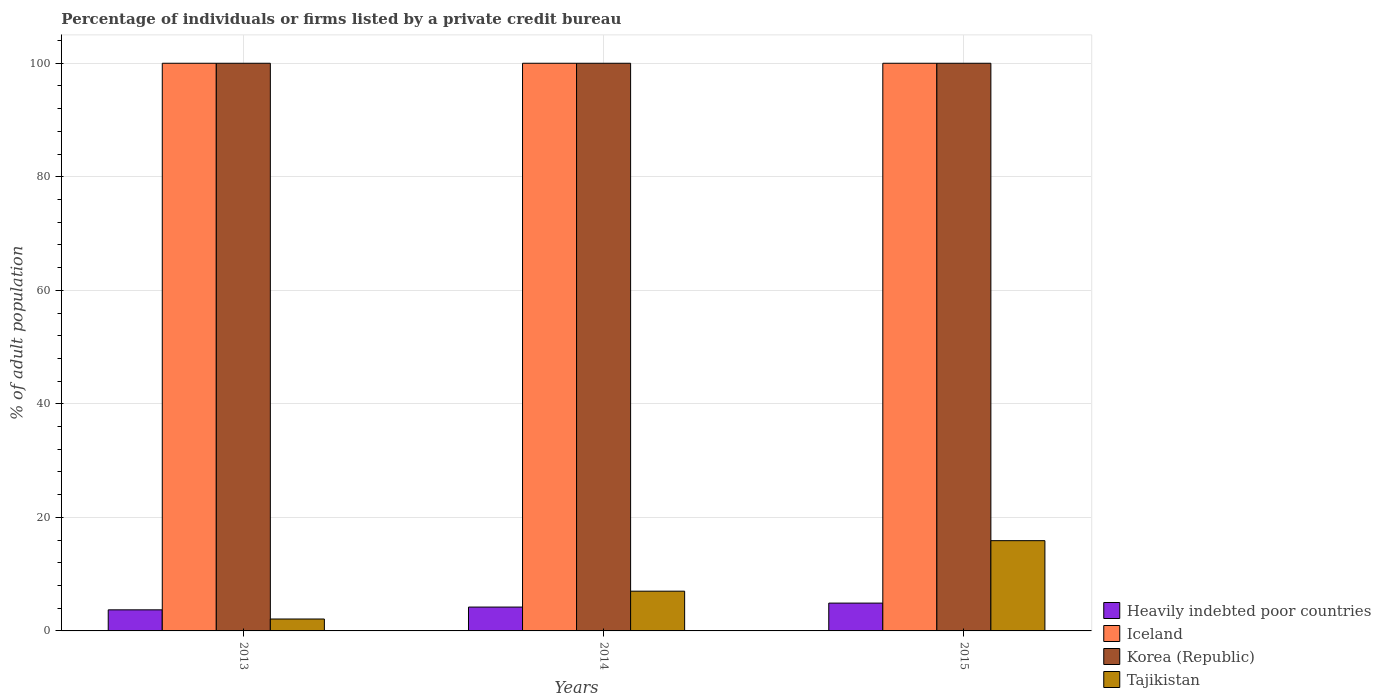How many groups of bars are there?
Your answer should be compact. 3. How many bars are there on the 3rd tick from the left?
Offer a very short reply. 4. What is the label of the 3rd group of bars from the left?
Offer a very short reply. 2015. What is the percentage of population listed by a private credit bureau in Iceland in 2014?
Ensure brevity in your answer.  100. In which year was the percentage of population listed by a private credit bureau in Iceland maximum?
Make the answer very short. 2013. In which year was the percentage of population listed by a private credit bureau in Iceland minimum?
Give a very brief answer. 2013. What is the total percentage of population listed by a private credit bureau in Korea (Republic) in the graph?
Your answer should be compact. 300. What is the difference between the percentage of population listed by a private credit bureau in Heavily indebted poor countries in 2014 and that in 2015?
Provide a succinct answer. -0.7. What is the difference between the percentage of population listed by a private credit bureau in Iceland in 2015 and the percentage of population listed by a private credit bureau in Korea (Republic) in 2014?
Provide a succinct answer. 0. What is the average percentage of population listed by a private credit bureau in Heavily indebted poor countries per year?
Provide a short and direct response. 4.27. In the year 2015, what is the difference between the percentage of population listed by a private credit bureau in Heavily indebted poor countries and percentage of population listed by a private credit bureau in Tajikistan?
Provide a succinct answer. -11. In how many years, is the percentage of population listed by a private credit bureau in Korea (Republic) greater than 56 %?
Your answer should be very brief. 3. What is the ratio of the percentage of population listed by a private credit bureau in Tajikistan in 2014 to that in 2015?
Your answer should be very brief. 0.44. Is the difference between the percentage of population listed by a private credit bureau in Heavily indebted poor countries in 2014 and 2015 greater than the difference between the percentage of population listed by a private credit bureau in Tajikistan in 2014 and 2015?
Your answer should be very brief. Yes. What is the difference between the highest and the second highest percentage of population listed by a private credit bureau in Tajikistan?
Offer a very short reply. 8.9. What does the 1st bar from the left in 2014 represents?
Make the answer very short. Heavily indebted poor countries. What does the 4th bar from the right in 2015 represents?
Offer a terse response. Heavily indebted poor countries. Are all the bars in the graph horizontal?
Your answer should be very brief. No. Are the values on the major ticks of Y-axis written in scientific E-notation?
Provide a short and direct response. No. Does the graph contain any zero values?
Give a very brief answer. No. Where does the legend appear in the graph?
Offer a very short reply. Bottom right. How are the legend labels stacked?
Ensure brevity in your answer.  Vertical. What is the title of the graph?
Your response must be concise. Percentage of individuals or firms listed by a private credit bureau. What is the label or title of the Y-axis?
Offer a very short reply. % of adult population. What is the % of adult population of Heavily indebted poor countries in 2013?
Give a very brief answer. 3.71. What is the % of adult population in Tajikistan in 2013?
Ensure brevity in your answer.  2.1. What is the % of adult population of Heavily indebted poor countries in 2014?
Offer a very short reply. 4.2. What is the % of adult population of Iceland in 2014?
Make the answer very short. 100. What is the % of adult population in Tajikistan in 2014?
Give a very brief answer. 7. What is the % of adult population of Heavily indebted poor countries in 2015?
Give a very brief answer. 4.9. Across all years, what is the maximum % of adult population in Heavily indebted poor countries?
Offer a terse response. 4.9. Across all years, what is the maximum % of adult population of Korea (Republic)?
Keep it short and to the point. 100. Across all years, what is the maximum % of adult population of Tajikistan?
Provide a short and direct response. 15.9. Across all years, what is the minimum % of adult population of Heavily indebted poor countries?
Your answer should be very brief. 3.71. Across all years, what is the minimum % of adult population in Tajikistan?
Your answer should be very brief. 2.1. What is the total % of adult population of Heavily indebted poor countries in the graph?
Offer a terse response. 12.82. What is the total % of adult population in Iceland in the graph?
Keep it short and to the point. 300. What is the total % of adult population of Korea (Republic) in the graph?
Offer a very short reply. 300. What is the total % of adult population in Tajikistan in the graph?
Give a very brief answer. 25. What is the difference between the % of adult population in Heavily indebted poor countries in 2013 and that in 2014?
Offer a terse response. -0.49. What is the difference between the % of adult population in Iceland in 2013 and that in 2014?
Offer a very short reply. 0. What is the difference between the % of adult population of Korea (Republic) in 2013 and that in 2014?
Provide a succinct answer. 0. What is the difference between the % of adult population in Tajikistan in 2013 and that in 2014?
Make the answer very short. -4.9. What is the difference between the % of adult population of Heavily indebted poor countries in 2013 and that in 2015?
Keep it short and to the point. -1.19. What is the difference between the % of adult population of Iceland in 2013 and that in 2015?
Your response must be concise. 0. What is the difference between the % of adult population of Heavily indebted poor countries in 2014 and that in 2015?
Your answer should be very brief. -0.7. What is the difference between the % of adult population in Iceland in 2014 and that in 2015?
Your response must be concise. 0. What is the difference between the % of adult population of Korea (Republic) in 2014 and that in 2015?
Make the answer very short. 0. What is the difference between the % of adult population in Heavily indebted poor countries in 2013 and the % of adult population in Iceland in 2014?
Provide a succinct answer. -96.29. What is the difference between the % of adult population of Heavily indebted poor countries in 2013 and the % of adult population of Korea (Republic) in 2014?
Offer a terse response. -96.29. What is the difference between the % of adult population in Heavily indebted poor countries in 2013 and the % of adult population in Tajikistan in 2014?
Keep it short and to the point. -3.29. What is the difference between the % of adult population in Iceland in 2013 and the % of adult population in Korea (Republic) in 2014?
Ensure brevity in your answer.  0. What is the difference between the % of adult population of Iceland in 2013 and the % of adult population of Tajikistan in 2014?
Your answer should be compact. 93. What is the difference between the % of adult population in Korea (Republic) in 2013 and the % of adult population in Tajikistan in 2014?
Provide a short and direct response. 93. What is the difference between the % of adult population in Heavily indebted poor countries in 2013 and the % of adult population in Iceland in 2015?
Offer a very short reply. -96.29. What is the difference between the % of adult population of Heavily indebted poor countries in 2013 and the % of adult population of Korea (Republic) in 2015?
Keep it short and to the point. -96.29. What is the difference between the % of adult population of Heavily indebted poor countries in 2013 and the % of adult population of Tajikistan in 2015?
Your response must be concise. -12.19. What is the difference between the % of adult population of Iceland in 2013 and the % of adult population of Tajikistan in 2015?
Provide a succinct answer. 84.1. What is the difference between the % of adult population in Korea (Republic) in 2013 and the % of adult population in Tajikistan in 2015?
Keep it short and to the point. 84.1. What is the difference between the % of adult population of Heavily indebted poor countries in 2014 and the % of adult population of Iceland in 2015?
Provide a succinct answer. -95.8. What is the difference between the % of adult population of Heavily indebted poor countries in 2014 and the % of adult population of Korea (Republic) in 2015?
Your response must be concise. -95.8. What is the difference between the % of adult population of Heavily indebted poor countries in 2014 and the % of adult population of Tajikistan in 2015?
Provide a short and direct response. -11.7. What is the difference between the % of adult population in Iceland in 2014 and the % of adult population in Tajikistan in 2015?
Your answer should be very brief. 84.1. What is the difference between the % of adult population in Korea (Republic) in 2014 and the % of adult population in Tajikistan in 2015?
Keep it short and to the point. 84.1. What is the average % of adult population of Heavily indebted poor countries per year?
Keep it short and to the point. 4.27. What is the average % of adult population of Iceland per year?
Offer a terse response. 100. What is the average % of adult population in Korea (Republic) per year?
Provide a short and direct response. 100. What is the average % of adult population of Tajikistan per year?
Keep it short and to the point. 8.33. In the year 2013, what is the difference between the % of adult population in Heavily indebted poor countries and % of adult population in Iceland?
Offer a terse response. -96.29. In the year 2013, what is the difference between the % of adult population of Heavily indebted poor countries and % of adult population of Korea (Republic)?
Your answer should be very brief. -96.29. In the year 2013, what is the difference between the % of adult population of Heavily indebted poor countries and % of adult population of Tajikistan?
Keep it short and to the point. 1.61. In the year 2013, what is the difference between the % of adult population in Iceland and % of adult population in Tajikistan?
Make the answer very short. 97.9. In the year 2013, what is the difference between the % of adult population in Korea (Republic) and % of adult population in Tajikistan?
Your answer should be compact. 97.9. In the year 2014, what is the difference between the % of adult population in Heavily indebted poor countries and % of adult population in Iceland?
Your answer should be compact. -95.8. In the year 2014, what is the difference between the % of adult population in Heavily indebted poor countries and % of adult population in Korea (Republic)?
Keep it short and to the point. -95.8. In the year 2014, what is the difference between the % of adult population in Heavily indebted poor countries and % of adult population in Tajikistan?
Make the answer very short. -2.8. In the year 2014, what is the difference between the % of adult population of Iceland and % of adult population of Tajikistan?
Keep it short and to the point. 93. In the year 2014, what is the difference between the % of adult population of Korea (Republic) and % of adult population of Tajikistan?
Your response must be concise. 93. In the year 2015, what is the difference between the % of adult population of Heavily indebted poor countries and % of adult population of Iceland?
Make the answer very short. -95.1. In the year 2015, what is the difference between the % of adult population in Heavily indebted poor countries and % of adult population in Korea (Republic)?
Your answer should be very brief. -95.1. In the year 2015, what is the difference between the % of adult population in Heavily indebted poor countries and % of adult population in Tajikistan?
Keep it short and to the point. -11. In the year 2015, what is the difference between the % of adult population in Iceland and % of adult population in Korea (Republic)?
Ensure brevity in your answer.  0. In the year 2015, what is the difference between the % of adult population in Iceland and % of adult population in Tajikistan?
Keep it short and to the point. 84.1. In the year 2015, what is the difference between the % of adult population of Korea (Republic) and % of adult population of Tajikistan?
Keep it short and to the point. 84.1. What is the ratio of the % of adult population of Heavily indebted poor countries in 2013 to that in 2014?
Provide a short and direct response. 0.88. What is the ratio of the % of adult population in Korea (Republic) in 2013 to that in 2014?
Your answer should be very brief. 1. What is the ratio of the % of adult population in Heavily indebted poor countries in 2013 to that in 2015?
Provide a succinct answer. 0.76. What is the ratio of the % of adult population of Tajikistan in 2013 to that in 2015?
Your answer should be very brief. 0.13. What is the ratio of the % of adult population of Heavily indebted poor countries in 2014 to that in 2015?
Give a very brief answer. 0.86. What is the ratio of the % of adult population in Iceland in 2014 to that in 2015?
Give a very brief answer. 1. What is the ratio of the % of adult population of Korea (Republic) in 2014 to that in 2015?
Provide a short and direct response. 1. What is the ratio of the % of adult population in Tajikistan in 2014 to that in 2015?
Your response must be concise. 0.44. What is the difference between the highest and the second highest % of adult population of Heavily indebted poor countries?
Provide a short and direct response. 0.7. What is the difference between the highest and the second highest % of adult population of Korea (Republic)?
Your response must be concise. 0. What is the difference between the highest and the second highest % of adult population of Tajikistan?
Give a very brief answer. 8.9. What is the difference between the highest and the lowest % of adult population in Heavily indebted poor countries?
Provide a short and direct response. 1.19. What is the difference between the highest and the lowest % of adult population of Iceland?
Your response must be concise. 0. What is the difference between the highest and the lowest % of adult population in Korea (Republic)?
Ensure brevity in your answer.  0. 